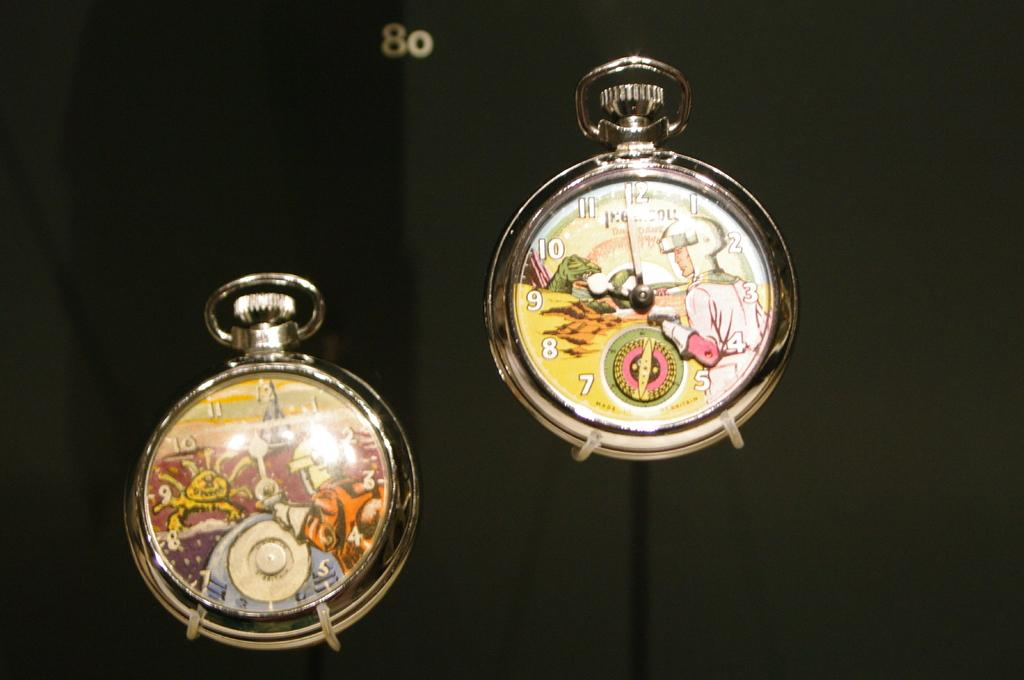<image>
Render a clear and concise summary of the photo. Two watches with cartoon images and the number 80 above the watches. 